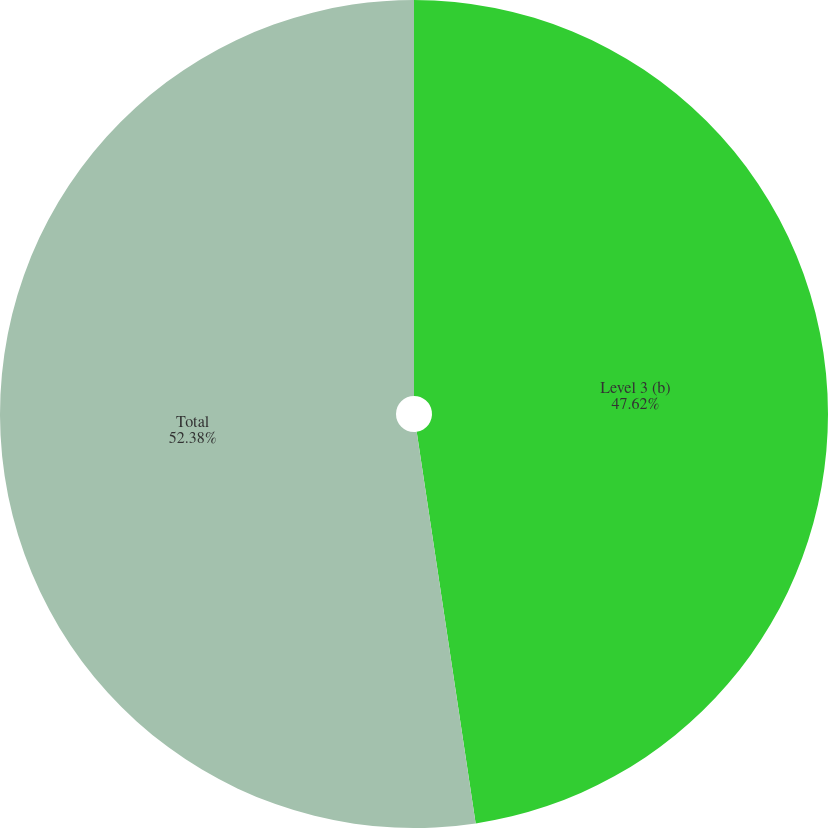<chart> <loc_0><loc_0><loc_500><loc_500><pie_chart><fcel>Level 3 (b)<fcel>Total<nl><fcel>47.62%<fcel>52.38%<nl></chart> 